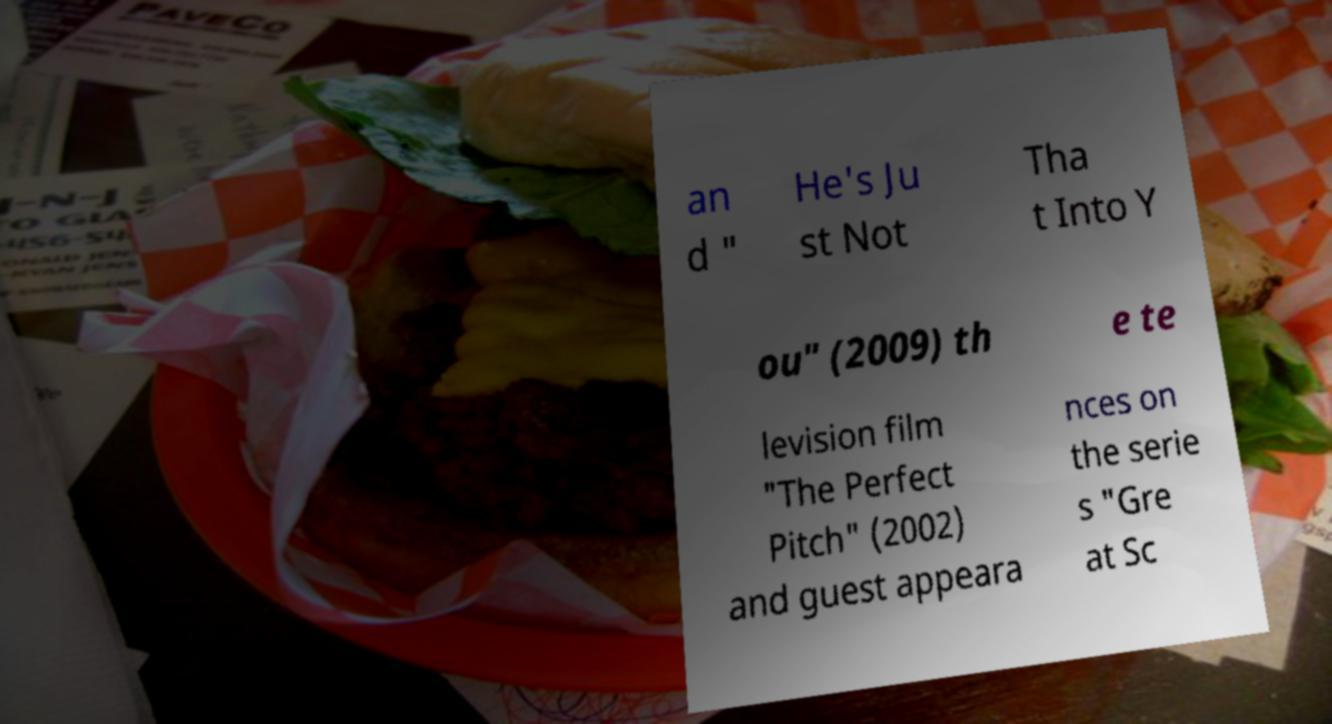Could you extract and type out the text from this image? an d " He's Ju st Not Tha t Into Y ou" (2009) th e te levision film "The Perfect Pitch" (2002) and guest appeara nces on the serie s "Gre at Sc 